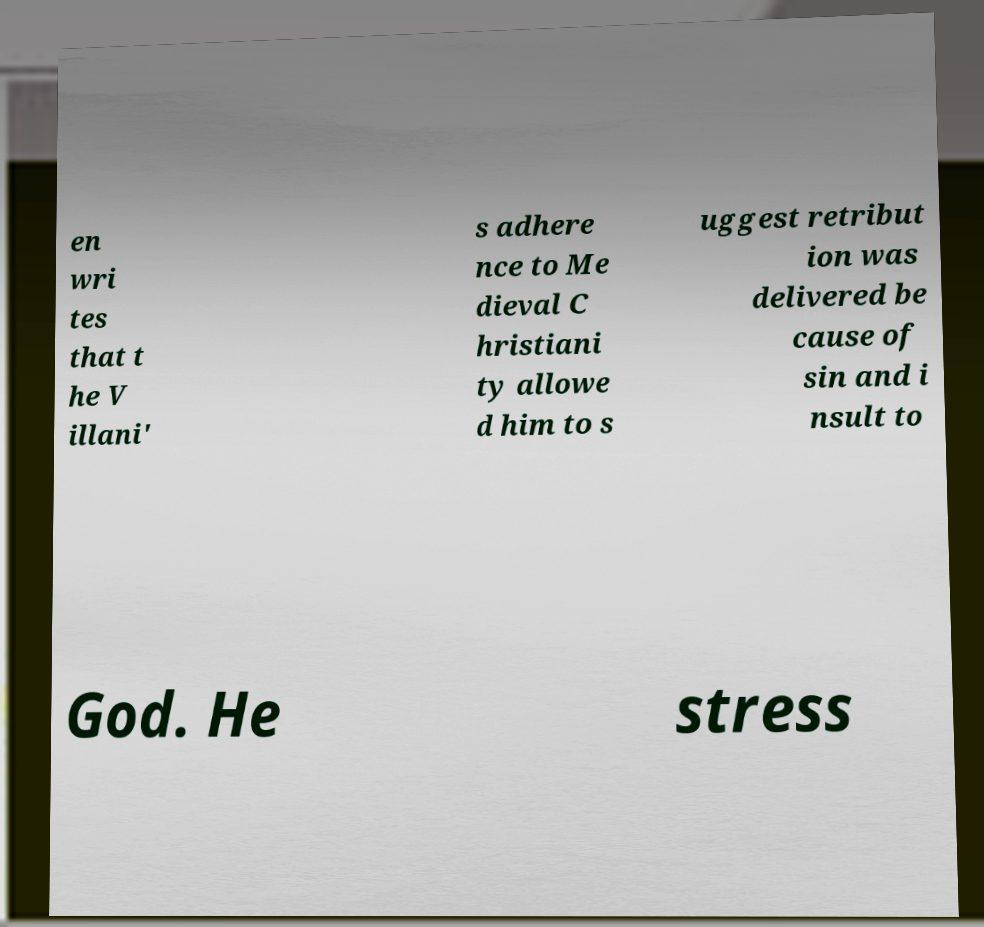I need the written content from this picture converted into text. Can you do that? en wri tes that t he V illani' s adhere nce to Me dieval C hristiani ty allowe d him to s uggest retribut ion was delivered be cause of sin and i nsult to God. He stress 